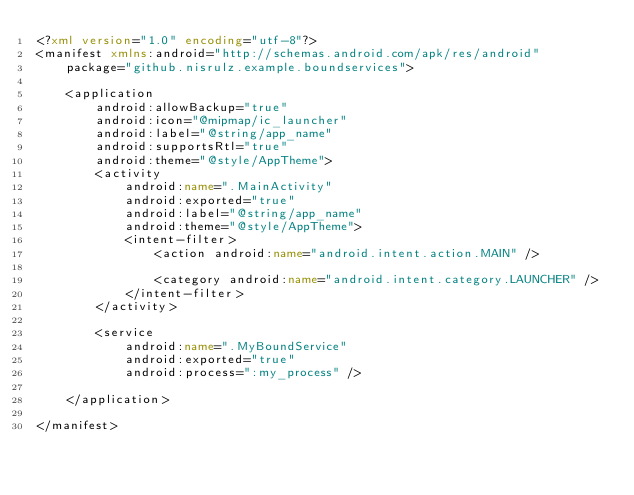Convert code to text. <code><loc_0><loc_0><loc_500><loc_500><_XML_><?xml version="1.0" encoding="utf-8"?>
<manifest xmlns:android="http://schemas.android.com/apk/res/android"
    package="github.nisrulz.example.boundservices">

    <application
        android:allowBackup="true"
        android:icon="@mipmap/ic_launcher"
        android:label="@string/app_name"
        android:supportsRtl="true"
        android:theme="@style/AppTheme">
        <activity
            android:name=".MainActivity"
            android:exported="true"
            android:label="@string/app_name"
            android:theme="@style/AppTheme">
            <intent-filter>
                <action android:name="android.intent.action.MAIN" />

                <category android:name="android.intent.category.LAUNCHER" />
            </intent-filter>
        </activity>

        <service
            android:name=".MyBoundService"
            android:exported="true"
            android:process=":my_process" />

    </application>

</manifest>
</code> 